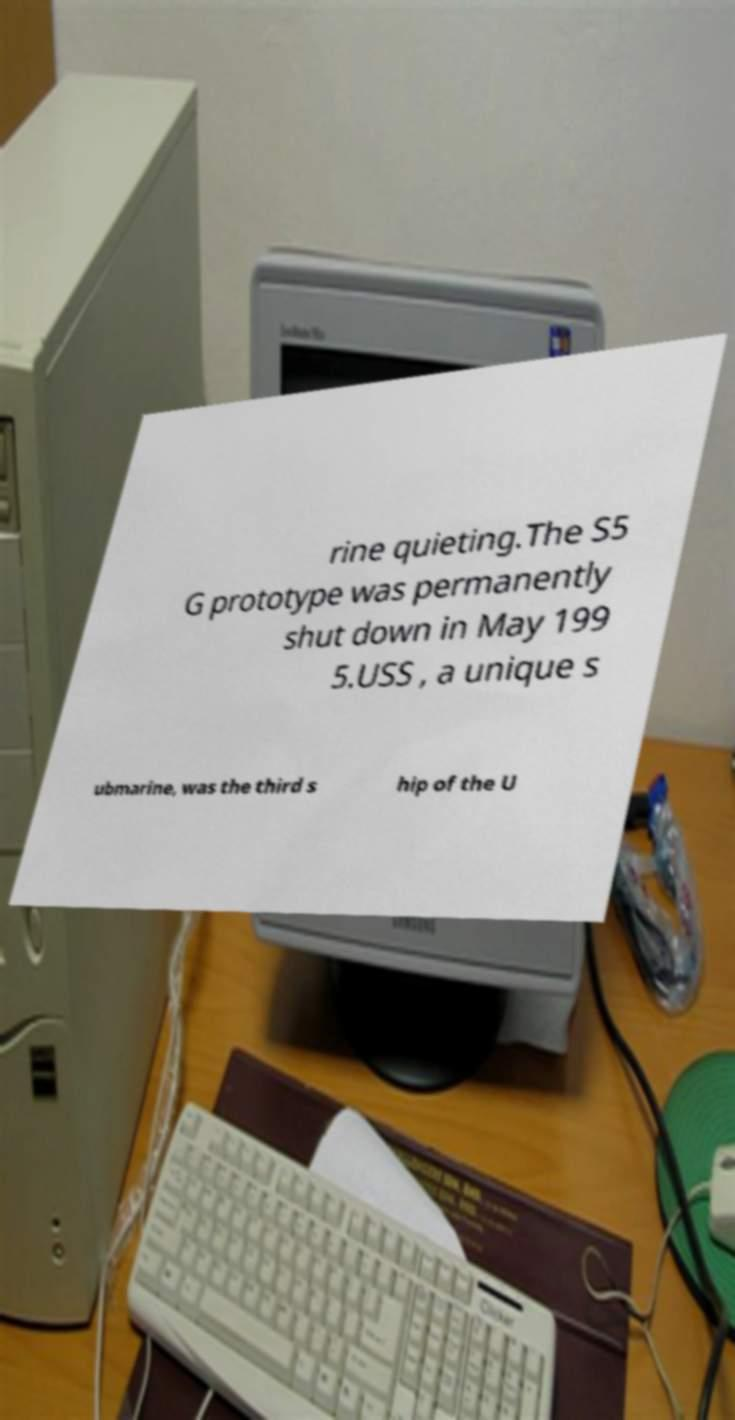For documentation purposes, I need the text within this image transcribed. Could you provide that? rine quieting.The S5 G prototype was permanently shut down in May 199 5.USS , a unique s ubmarine, was the third s hip of the U 